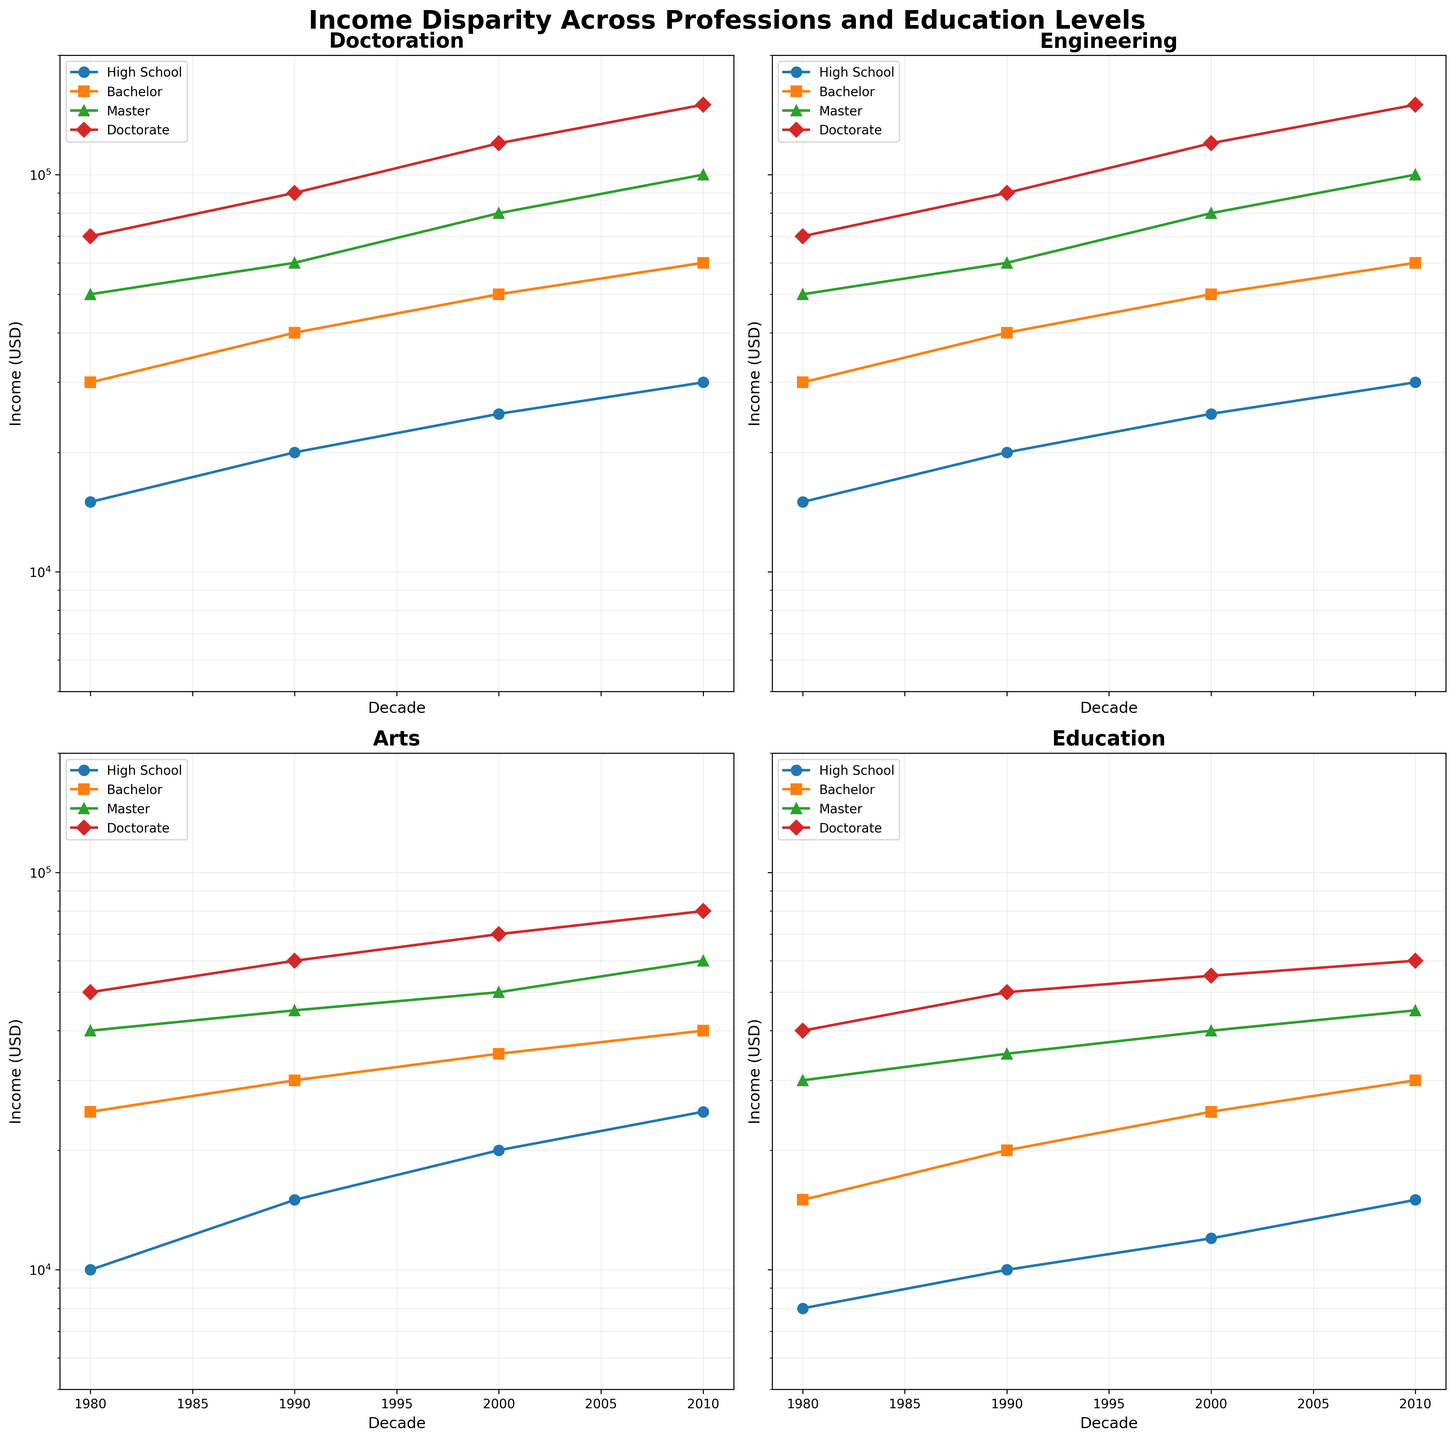What is the title of the figure? The title is displayed at the top of the figure in bold and large font size. It provides a summary of the information being visualized in the subplots.
Answer: Income Disparity Across Professions and Education Levels Which decade shows the highest income for 'Doctoration' profession with a 'Doctorate' education level? Locate the subplot for 'Doctoration' profession. Identify the line representing 'Doctorate' education. Find the data point on this line corresponding to the highest decade value.
Answer: 2010 How does the income of 'Arts' profession with a 'Bachelor' level change from 1980 to 2010? Locate the subplot for 'Arts' profession. Identify the 'Bachelor' education level line. Note the income values at 1980 and 2010 and find the difference.
Answer: Increases from 25000 to 40000 Which profession shows the smallest income disparity among different education levels in 2010? Compare income ranges for all education levels across all professions in 2010. Identify the profession with the smallest range between the highest and lowest income values.
Answer: Education How does the income for 'Engineering' profession with a 'Master' education level in 2000 compare to 'Doctoration' with 'High School' in 2010? Locate the specific points in the subplots for each profession and education level. Read the income values and compare them.
Answer: 80000 for Engineering (Master) in 2000 is higher than 30000 for Doctoration (High School) in 2010 By how much did the income for 'Education' profession with a 'Doctorate' level increase from 1980 to 2010? Find the 'Education' subplot and locate the 'Doctorate' education level line. Note the income values at 1980 and 2010. Calculate the difference between these two values.
Answer: Increase of 20000 (from 40000 to 60000) What is the trend of income over decades for 'Engineering' profession with a 'High School' education level? Locate the subplot for 'Engineering' profession. Identify the 'High School' education level line. Observe how the income values change across the decades.
Answer: Steadily increasing Which education level line in 'Arts' profession has the steepest increase from 1980 to 2010? In the 'Arts' subplot, compare the slopes of the lines for each education level from 1980 to 2010. Identify the line with the steepest increase.
Answer: Doctorate Does the income for 'Education' profession with a 'Bachelor' level surpass the income for 'Arts' profession with a 'High School' level in any decade? Compare the 'Education' Bachelor line and 'Arts' High School line in the respective subplots across all decades. Check if 'Education' Bachelor income surpasses 'Arts' High School income at any point.
Answer: Yes, from 2000 onwards Which profession sees the highest income value recorded in the entire figure? Identify the data point with the highest income across all subplots and education levels.
Answer: 'Doctoration' profession with 'Doctorate' education level in 2010 (150000) 